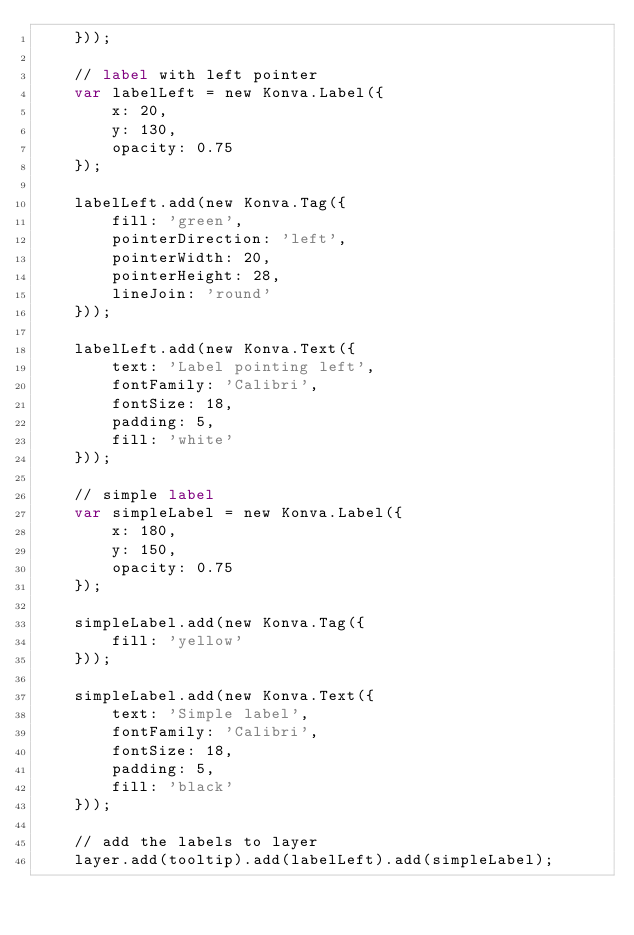Convert code to text. <code><loc_0><loc_0><loc_500><loc_500><_HTML_>    }));

    // label with left pointer
    var labelLeft = new Konva.Label({
        x: 20,
        y: 130,
        opacity: 0.75
    });

    labelLeft.add(new Konva.Tag({
        fill: 'green',
        pointerDirection: 'left',
        pointerWidth: 20,
        pointerHeight: 28,
        lineJoin: 'round'
    }));

    labelLeft.add(new Konva.Text({
        text: 'Label pointing left',
        fontFamily: 'Calibri',
        fontSize: 18,
        padding: 5,
        fill: 'white'
    }));

    // simple label
    var simpleLabel = new Konva.Label({
        x: 180,
        y: 150,
        opacity: 0.75
    });

    simpleLabel.add(new Konva.Tag({
        fill: 'yellow'
    }));

    simpleLabel.add(new Konva.Text({
        text: 'Simple label',
        fontFamily: 'Calibri',
        fontSize: 18,
        padding: 5,
        fill: 'black'
    }));

    // add the labels to layer
    layer.add(tooltip).add(labelLeft).add(simpleLabel);
</code> 